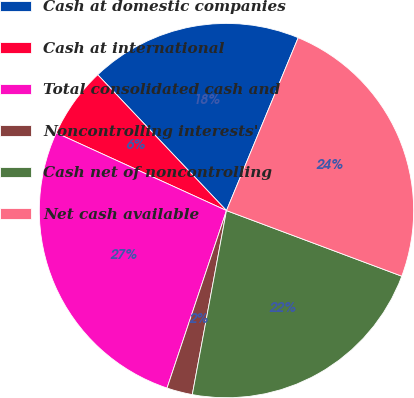Convert chart to OTSL. <chart><loc_0><loc_0><loc_500><loc_500><pie_chart><fcel>Cash at domestic companies<fcel>Cash at international<fcel>Total consolidated cash and<fcel>Noncontrolling interests'<fcel>Cash net of noncontrolling<fcel>Net cash available<nl><fcel>18.33%<fcel>6.11%<fcel>26.67%<fcel>2.22%<fcel>22.22%<fcel>24.44%<nl></chart> 